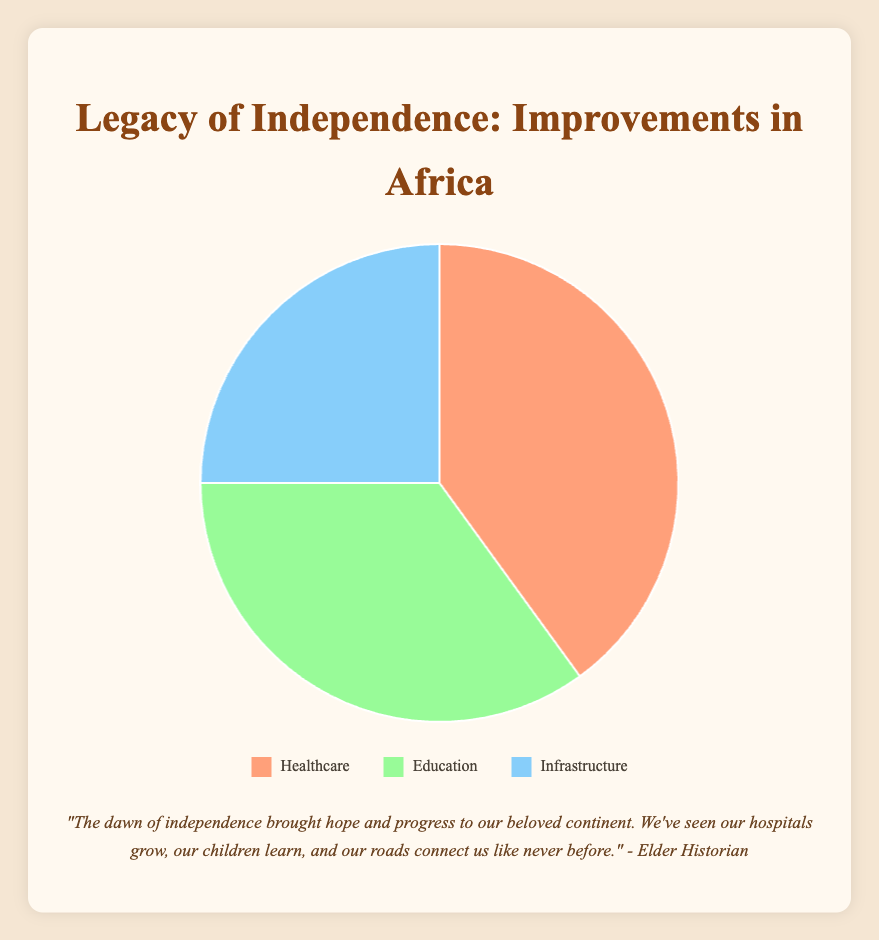Which category received the largest improvement post-independence? The figure shows Healthcare, Education, and Infrastructure improvements. Healthcare occupies the largest section of the pie chart.
Answer: Healthcare What percentage of improvements is attributed to Education? The corresponding segment of the pie chart for Education shows a percentage value of 35%.
Answer: 35% Which category has the smallest improvement and what is its percentage? The pie chart shows that Infrastructure has the smallest segment, and the corresponding percentage value is 25%.
Answer: Infrastructure, 25% How much greater is the improvement in Healthcare compared to Infrastructure? Healthcare is 40% and Infrastructure is 25%. The difference is calculated as 40% - 25% = 15%.
Answer: 15% What is the combined percentage of improvements in Healthcare and Education? Healthcare contributes 40% and Education contributes 35%. The combined percentage is 40% + 35% = 75%.
Answer: 75% How does the improvement in Education compare to Infrastructure? The segment for Education shows 35%, which is greater than the 25% for Infrastructure. Hence, improvements in Education are 10% greater than those in Infrastructure.
Answer: 10% greater What color represents the Healthcare segment of the pie chart? The visual attribute for Healthcare in the legend shows an orange color.
Answer: Orange If the total improvements made post-independence are considered to be 100%, how much combined improvement has been made in categories other than Healthcare? Healthcare occupies 40%, so the combined improvement for the other categories (Education and Infrastructure) is 100% - 40% = 60%.
Answer: 60% By how many percentage points is the improvement in Education larger than in Infrastructure? Education shows 35% and Infrastructure shows 25%. The difference is calculated as 35% - 25%.
Answer: 10 percentage points What color represents the segment that shows the least improvement? The legend shows that the least improved category (Infrastructure) is represented by a blue color.
Answer: Blue 